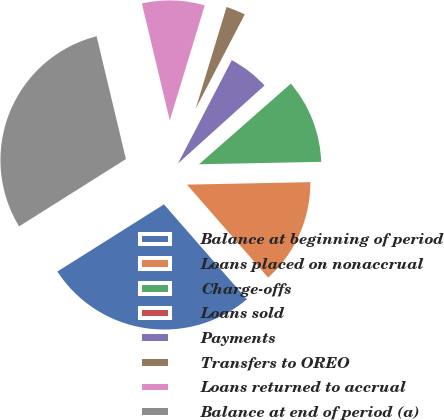Convert chart to OTSL. <chart><loc_0><loc_0><loc_500><loc_500><pie_chart><fcel>Balance at beginning of period<fcel>Loans placed on nonaccrual<fcel>Charge-offs<fcel>Loans sold<fcel>Payments<fcel>Transfers to OREO<fcel>Loans returned to accrual<fcel>Balance at end of period (a)<nl><fcel>27.48%<fcel>13.89%<fcel>11.15%<fcel>0.21%<fcel>5.68%<fcel>2.95%<fcel>8.42%<fcel>30.22%<nl></chart> 